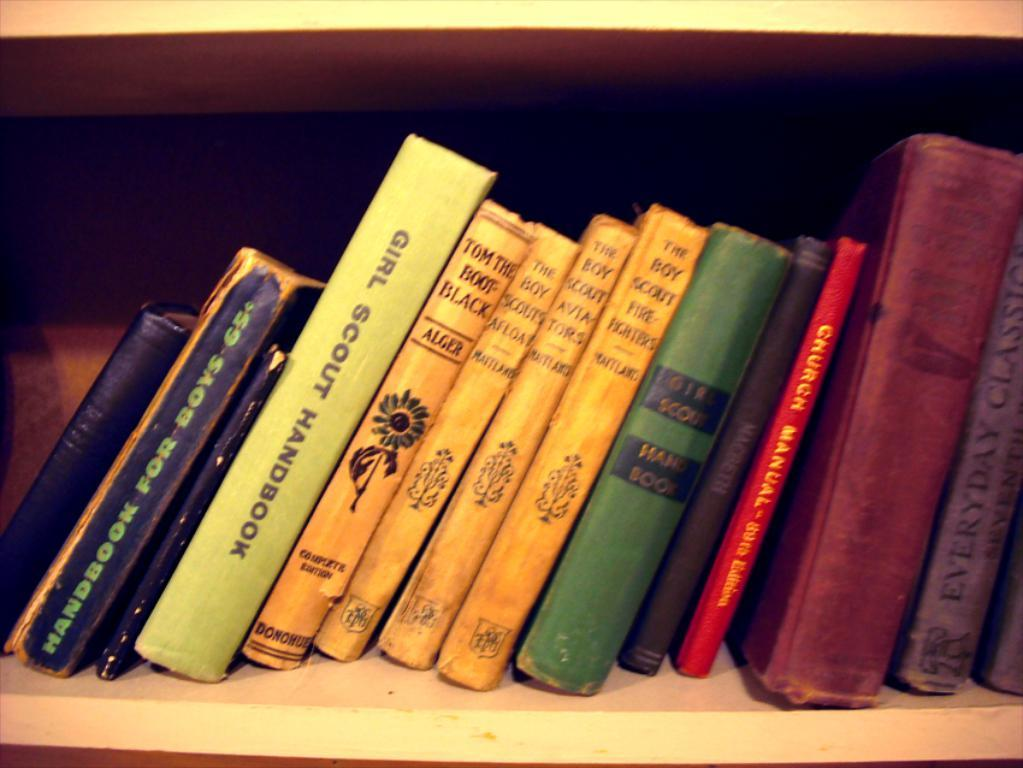Provide a one-sentence caption for the provided image. Books on a bookshelf containing a Girl Scout Handbook. 